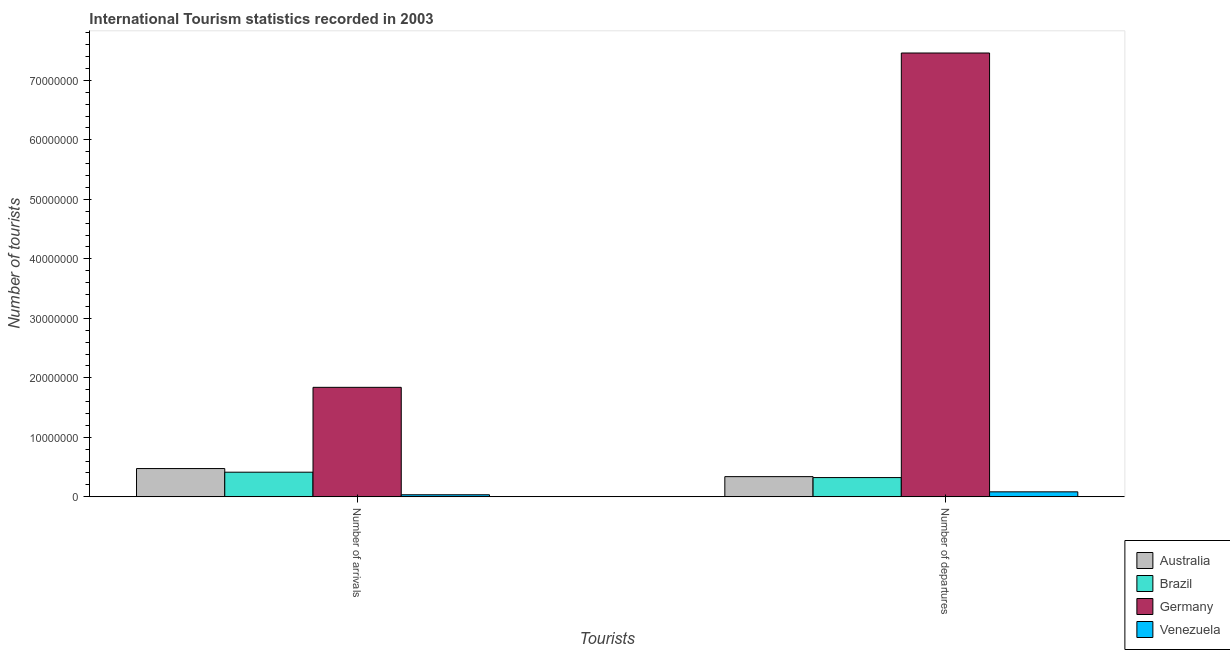How many different coloured bars are there?
Your response must be concise. 4. Are the number of bars on each tick of the X-axis equal?
Keep it short and to the point. Yes. How many bars are there on the 1st tick from the right?
Keep it short and to the point. 4. What is the label of the 2nd group of bars from the left?
Make the answer very short. Number of departures. What is the number of tourist arrivals in Venezuela?
Give a very brief answer. 3.37e+05. Across all countries, what is the maximum number of tourist arrivals?
Your answer should be very brief. 1.84e+07. Across all countries, what is the minimum number of tourist departures?
Your answer should be compact. 8.32e+05. In which country was the number of tourist departures minimum?
Your answer should be very brief. Venezuela. What is the total number of tourist arrivals in the graph?
Give a very brief answer. 2.76e+07. What is the difference between the number of tourist departures in Germany and that in Venezuela?
Your answer should be compact. 7.38e+07. What is the difference between the number of tourist departures in Venezuela and the number of tourist arrivals in Brazil?
Offer a terse response. -3.30e+06. What is the average number of tourist departures per country?
Ensure brevity in your answer.  2.05e+07. What is the difference between the number of tourist departures and number of tourist arrivals in Venezuela?
Your response must be concise. 4.95e+05. What is the ratio of the number of tourist departures in Australia to that in Venezuela?
Your answer should be very brief. 4.07. What does the 2nd bar from the left in Number of arrivals represents?
Offer a terse response. Brazil. What does the 2nd bar from the right in Number of departures represents?
Keep it short and to the point. Germany. How many bars are there?
Provide a short and direct response. 8. Are all the bars in the graph horizontal?
Keep it short and to the point. No. How many countries are there in the graph?
Your answer should be compact. 4. Are the values on the major ticks of Y-axis written in scientific E-notation?
Offer a very short reply. No. Does the graph contain any zero values?
Ensure brevity in your answer.  No. Does the graph contain grids?
Offer a very short reply. No. How many legend labels are there?
Your answer should be very brief. 4. How are the legend labels stacked?
Provide a succinct answer. Vertical. What is the title of the graph?
Keep it short and to the point. International Tourism statistics recorded in 2003. Does "High income: nonOECD" appear as one of the legend labels in the graph?
Keep it short and to the point. No. What is the label or title of the X-axis?
Your response must be concise. Tourists. What is the label or title of the Y-axis?
Offer a terse response. Number of tourists. What is the Number of tourists of Australia in Number of arrivals?
Offer a very short reply. 4.75e+06. What is the Number of tourists in Brazil in Number of arrivals?
Your response must be concise. 4.13e+06. What is the Number of tourists in Germany in Number of arrivals?
Your response must be concise. 1.84e+07. What is the Number of tourists of Venezuela in Number of arrivals?
Keep it short and to the point. 3.37e+05. What is the Number of tourists of Australia in Number of departures?
Keep it short and to the point. 3.39e+06. What is the Number of tourists in Brazil in Number of departures?
Your response must be concise. 3.23e+06. What is the Number of tourists of Germany in Number of departures?
Give a very brief answer. 7.46e+07. What is the Number of tourists of Venezuela in Number of departures?
Your answer should be compact. 8.32e+05. Across all Tourists, what is the maximum Number of tourists of Australia?
Ensure brevity in your answer.  4.75e+06. Across all Tourists, what is the maximum Number of tourists of Brazil?
Keep it short and to the point. 4.13e+06. Across all Tourists, what is the maximum Number of tourists of Germany?
Provide a short and direct response. 7.46e+07. Across all Tourists, what is the maximum Number of tourists in Venezuela?
Offer a very short reply. 8.32e+05. Across all Tourists, what is the minimum Number of tourists in Australia?
Provide a short and direct response. 3.39e+06. Across all Tourists, what is the minimum Number of tourists in Brazil?
Your answer should be very brief. 3.23e+06. Across all Tourists, what is the minimum Number of tourists in Germany?
Make the answer very short. 1.84e+07. Across all Tourists, what is the minimum Number of tourists of Venezuela?
Offer a terse response. 3.37e+05. What is the total Number of tourists of Australia in the graph?
Ensure brevity in your answer.  8.13e+06. What is the total Number of tourists in Brazil in the graph?
Provide a succinct answer. 7.36e+06. What is the total Number of tourists in Germany in the graph?
Your answer should be very brief. 9.30e+07. What is the total Number of tourists in Venezuela in the graph?
Give a very brief answer. 1.17e+06. What is the difference between the Number of tourists in Australia in Number of arrivals and that in Number of departures?
Provide a short and direct response. 1.36e+06. What is the difference between the Number of tourists of Brazil in Number of arrivals and that in Number of departures?
Provide a short and direct response. 9.04e+05. What is the difference between the Number of tourists in Germany in Number of arrivals and that in Number of departures?
Provide a succinct answer. -5.62e+07. What is the difference between the Number of tourists in Venezuela in Number of arrivals and that in Number of departures?
Keep it short and to the point. -4.95e+05. What is the difference between the Number of tourists in Australia in Number of arrivals and the Number of tourists in Brazil in Number of departures?
Provide a succinct answer. 1.52e+06. What is the difference between the Number of tourists of Australia in Number of arrivals and the Number of tourists of Germany in Number of departures?
Offer a very short reply. -6.99e+07. What is the difference between the Number of tourists of Australia in Number of arrivals and the Number of tourists of Venezuela in Number of departures?
Make the answer very short. 3.91e+06. What is the difference between the Number of tourists of Brazil in Number of arrivals and the Number of tourists of Germany in Number of departures?
Your answer should be very brief. -7.05e+07. What is the difference between the Number of tourists in Brazil in Number of arrivals and the Number of tourists in Venezuela in Number of departures?
Provide a succinct answer. 3.30e+06. What is the difference between the Number of tourists in Germany in Number of arrivals and the Number of tourists in Venezuela in Number of departures?
Keep it short and to the point. 1.76e+07. What is the average Number of tourists in Australia per Tourists?
Ensure brevity in your answer.  4.07e+06. What is the average Number of tourists of Brazil per Tourists?
Give a very brief answer. 3.68e+06. What is the average Number of tourists in Germany per Tourists?
Offer a very short reply. 4.65e+07. What is the average Number of tourists of Venezuela per Tourists?
Give a very brief answer. 5.84e+05. What is the difference between the Number of tourists in Australia and Number of tourists in Brazil in Number of arrivals?
Keep it short and to the point. 6.13e+05. What is the difference between the Number of tourists of Australia and Number of tourists of Germany in Number of arrivals?
Your response must be concise. -1.37e+07. What is the difference between the Number of tourists of Australia and Number of tourists of Venezuela in Number of arrivals?
Give a very brief answer. 4.41e+06. What is the difference between the Number of tourists of Brazil and Number of tourists of Germany in Number of arrivals?
Offer a very short reply. -1.43e+07. What is the difference between the Number of tourists of Brazil and Number of tourists of Venezuela in Number of arrivals?
Your response must be concise. 3.80e+06. What is the difference between the Number of tourists in Germany and Number of tourists in Venezuela in Number of arrivals?
Keep it short and to the point. 1.81e+07. What is the difference between the Number of tourists in Australia and Number of tourists in Brazil in Number of departures?
Keep it short and to the point. 1.59e+05. What is the difference between the Number of tourists in Australia and Number of tourists in Germany in Number of departures?
Ensure brevity in your answer.  -7.12e+07. What is the difference between the Number of tourists in Australia and Number of tourists in Venezuela in Number of departures?
Your response must be concise. 2.56e+06. What is the difference between the Number of tourists of Brazil and Number of tourists of Germany in Number of departures?
Offer a very short reply. -7.14e+07. What is the difference between the Number of tourists in Brazil and Number of tourists in Venezuela in Number of departures?
Provide a succinct answer. 2.40e+06. What is the difference between the Number of tourists in Germany and Number of tourists in Venezuela in Number of departures?
Keep it short and to the point. 7.38e+07. What is the ratio of the Number of tourists in Australia in Number of arrivals to that in Number of departures?
Make the answer very short. 1.4. What is the ratio of the Number of tourists in Brazil in Number of arrivals to that in Number of departures?
Provide a succinct answer. 1.28. What is the ratio of the Number of tourists in Germany in Number of arrivals to that in Number of departures?
Provide a succinct answer. 0.25. What is the ratio of the Number of tourists in Venezuela in Number of arrivals to that in Number of departures?
Provide a short and direct response. 0.41. What is the difference between the highest and the second highest Number of tourists in Australia?
Your answer should be very brief. 1.36e+06. What is the difference between the highest and the second highest Number of tourists of Brazil?
Ensure brevity in your answer.  9.04e+05. What is the difference between the highest and the second highest Number of tourists in Germany?
Provide a succinct answer. 5.62e+07. What is the difference between the highest and the second highest Number of tourists of Venezuela?
Provide a short and direct response. 4.95e+05. What is the difference between the highest and the lowest Number of tourists of Australia?
Your response must be concise. 1.36e+06. What is the difference between the highest and the lowest Number of tourists in Brazil?
Offer a terse response. 9.04e+05. What is the difference between the highest and the lowest Number of tourists in Germany?
Offer a very short reply. 5.62e+07. What is the difference between the highest and the lowest Number of tourists of Venezuela?
Your response must be concise. 4.95e+05. 